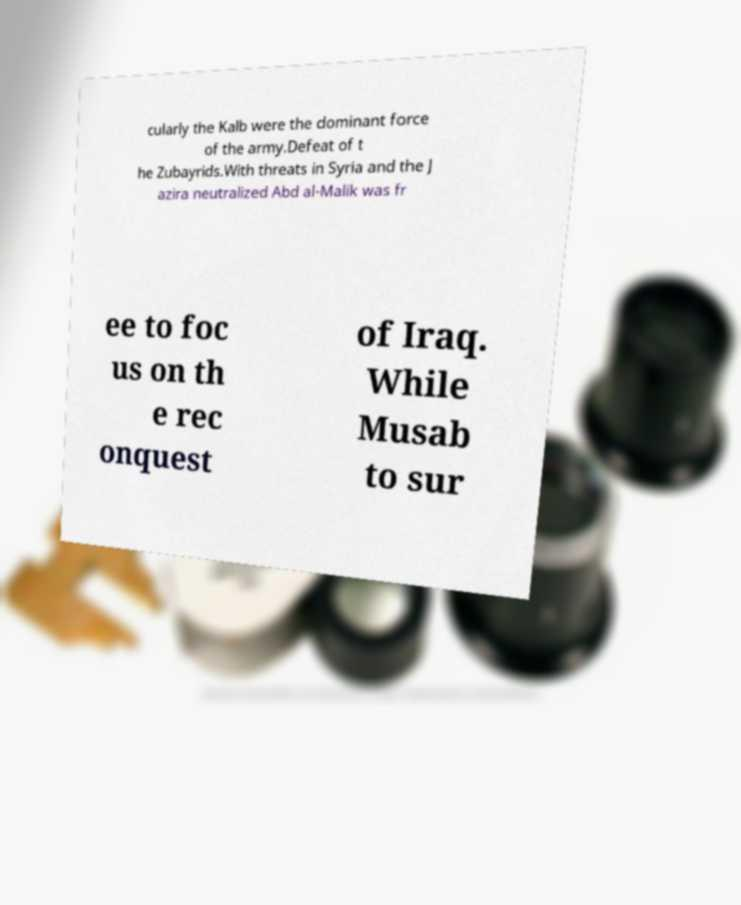Please read and relay the text visible in this image. What does it say? cularly the Kalb were the dominant force of the army.Defeat of t he Zubayrids.With threats in Syria and the J azira neutralized Abd al-Malik was fr ee to foc us on th e rec onquest of Iraq. While Musab to sur 